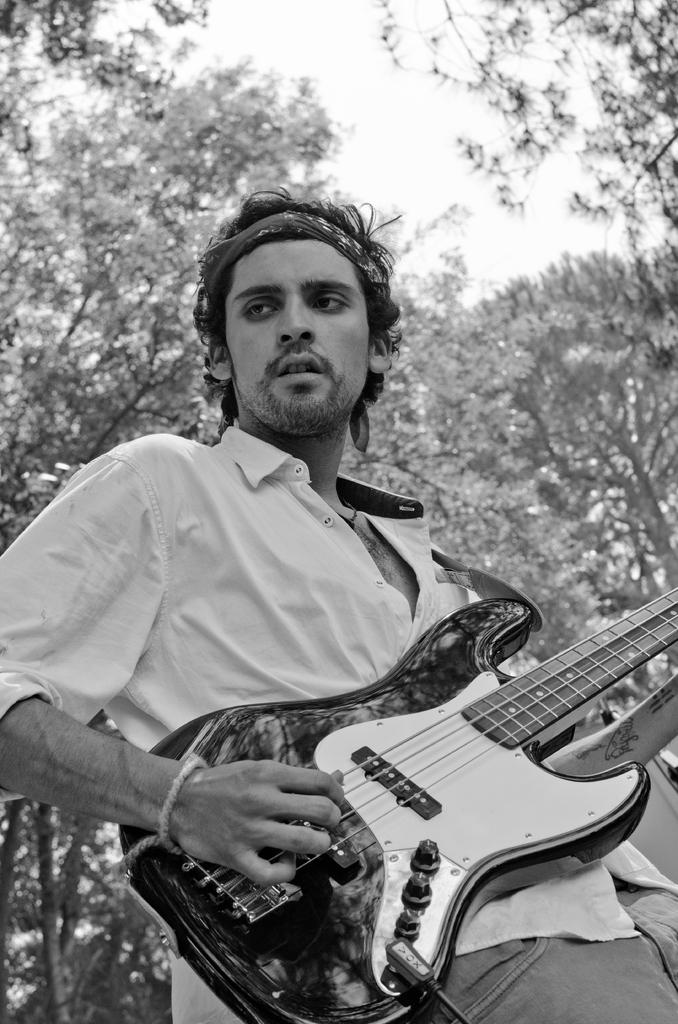What is the color scheme of the image? The image is black and white. What is the person in the image doing? The person is standing and holding a guitar. What can be seen in the background of the image? There are trees and the sky visible in the background. How much profit did the woman make from the brick in the image? There is no woman or brick present in the image, so it is not possible to determine any profit made. 